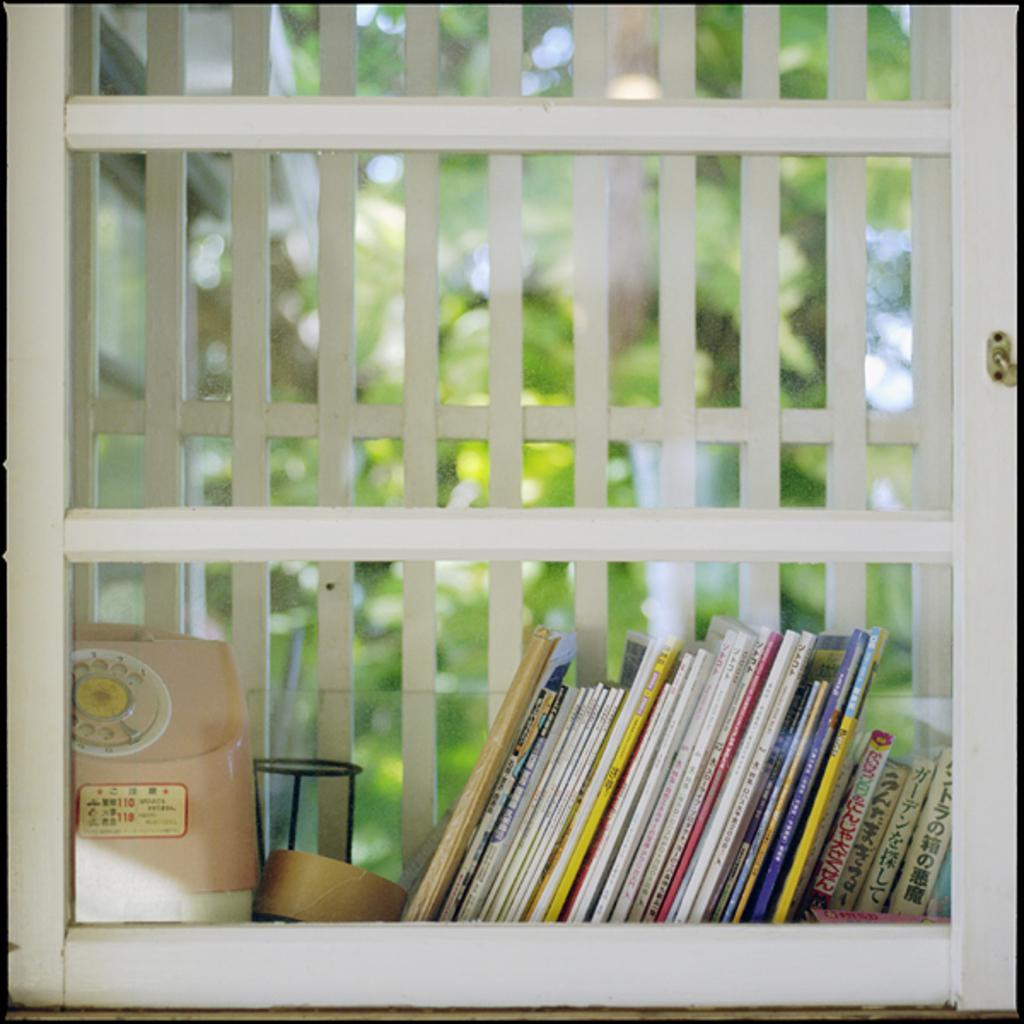What type of items can be seen in the image? There are books and objects placed in a rack in the image. Can you describe the background of the image? There are trees visible in the background through a glass. What type of tooth is visible in the image? There is no tooth visible in the image. Who is the manager in the image? There is no manager present in the image. 